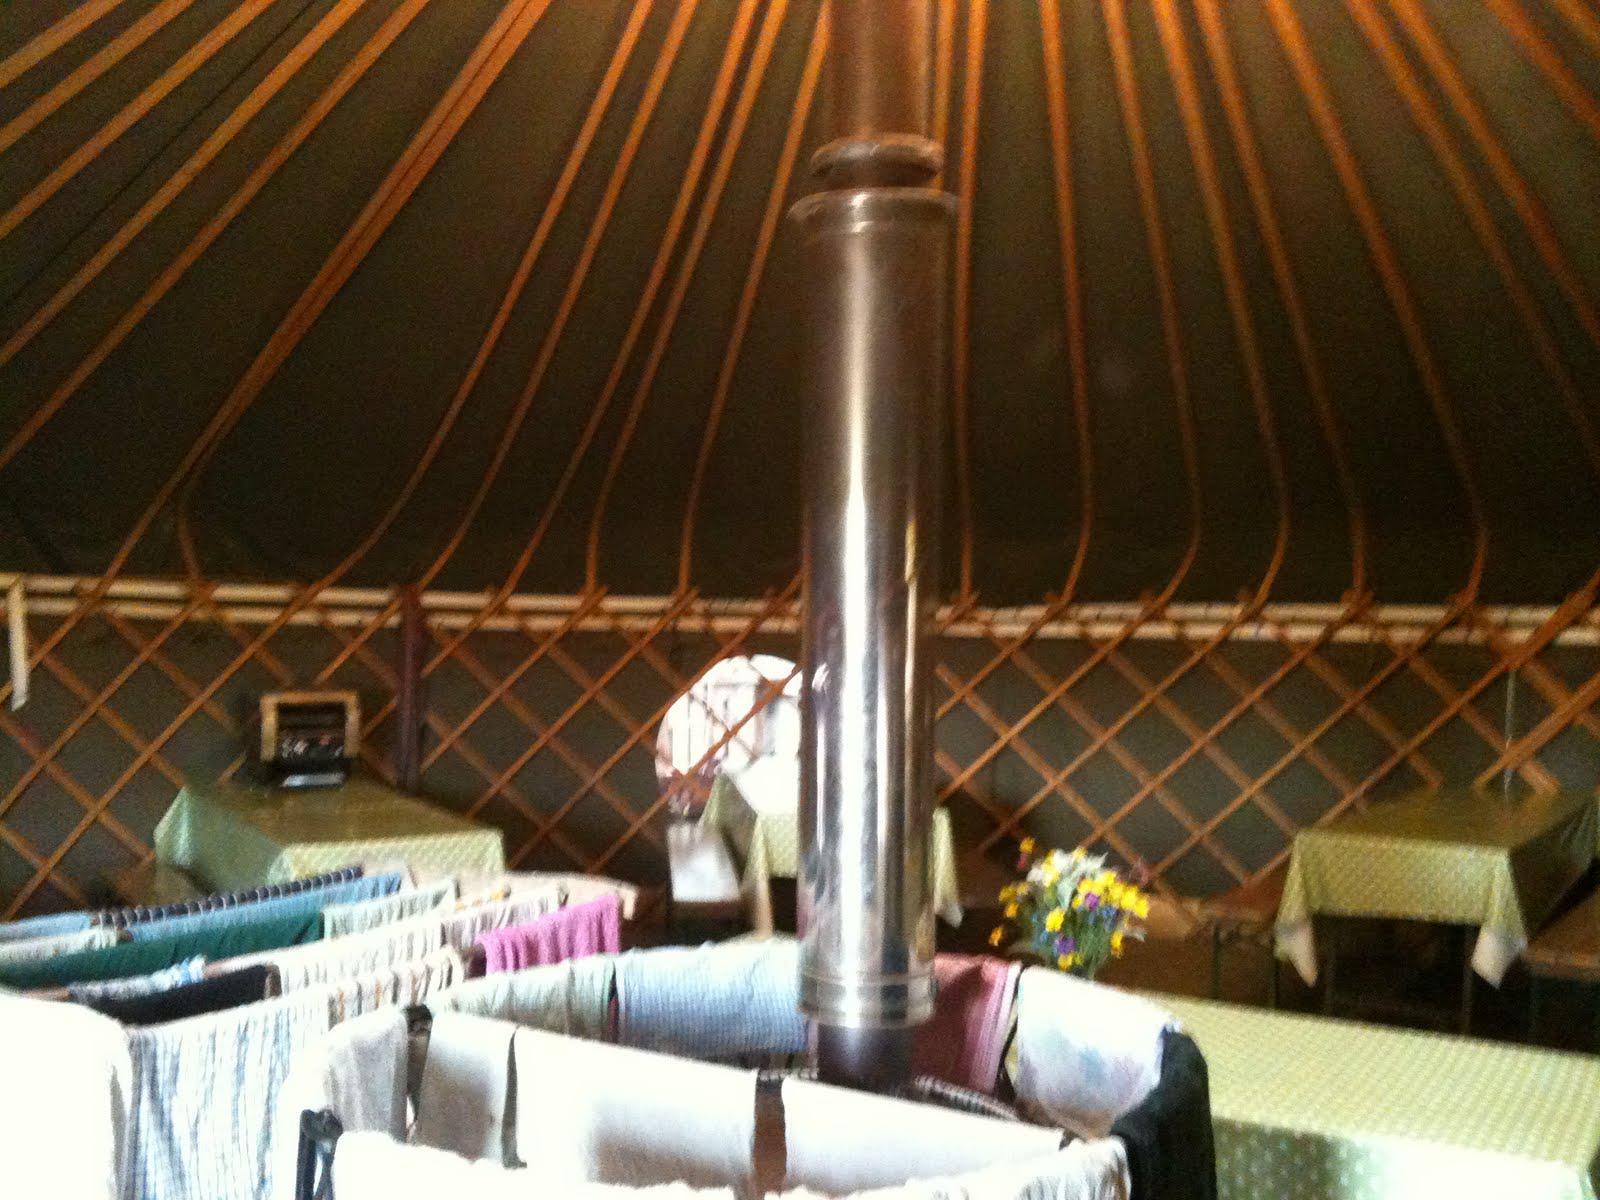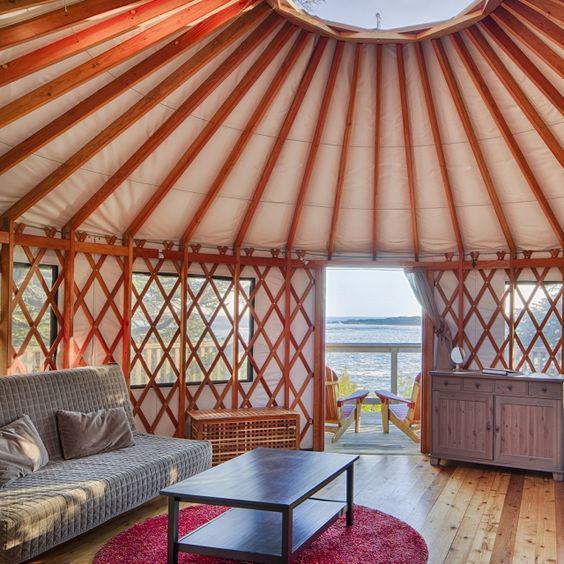The first image is the image on the left, the second image is the image on the right. Assess this claim about the two images: "A bed sits on the ground floor of the hut in at least one of the images.". Correct or not? Answer yes or no. No. The first image is the image on the left, the second image is the image on the right. Assess this claim about the two images: "A ladder to a loft is standing at the right in an image of a yurt's interior.". Correct or not? Answer yes or no. No. 